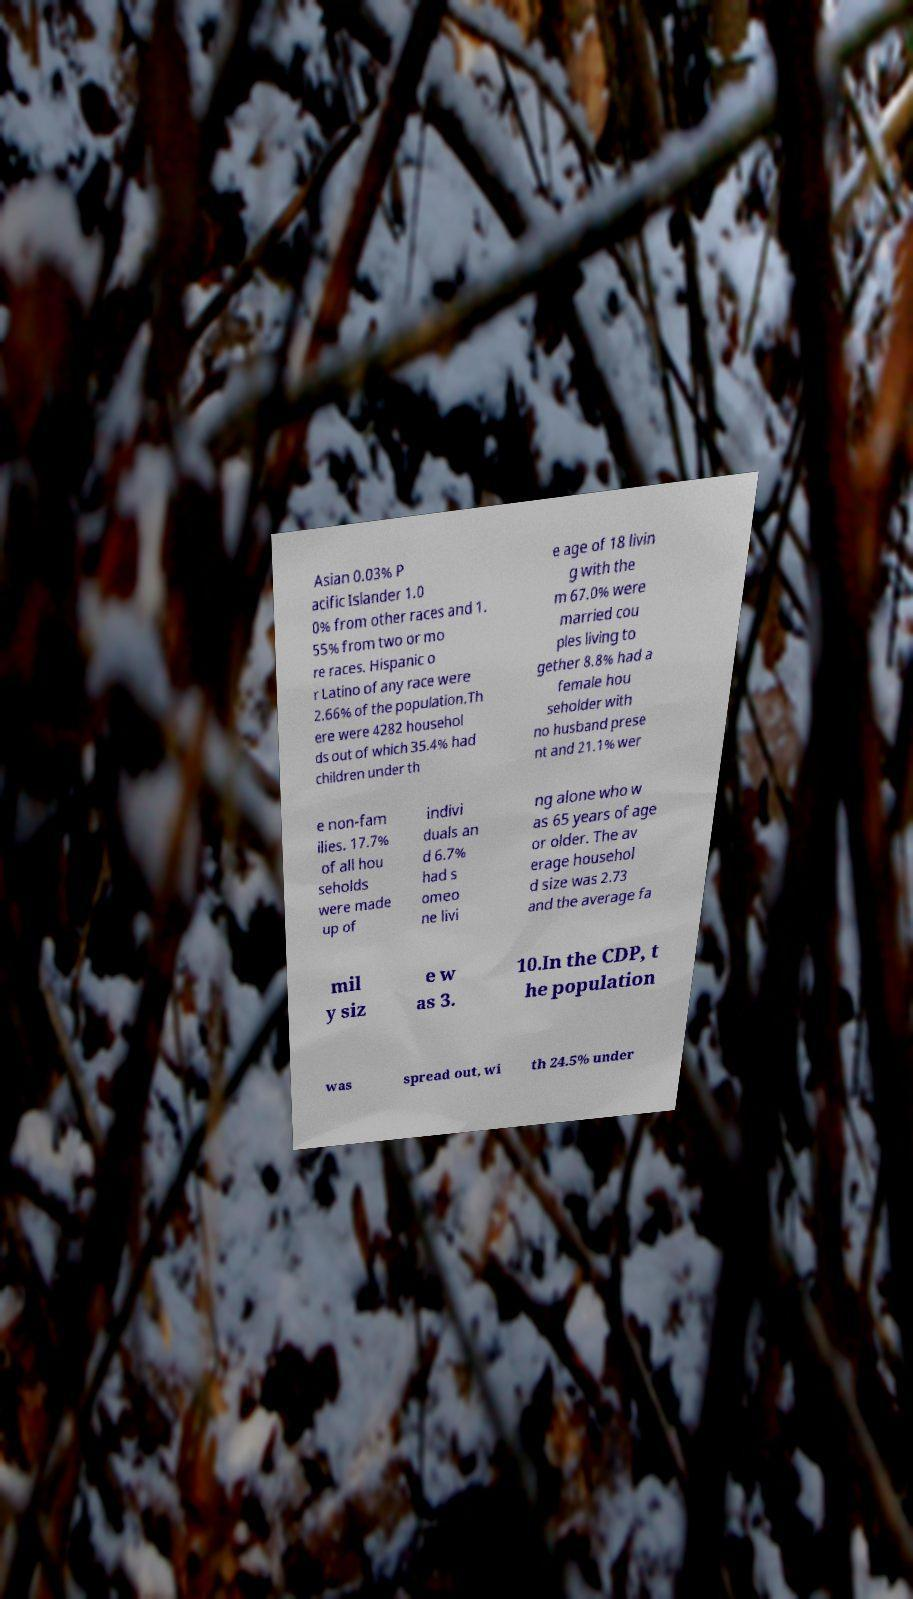I need the written content from this picture converted into text. Can you do that? Asian 0.03% P acific Islander 1.0 0% from other races and 1. 55% from two or mo re races. Hispanic o r Latino of any race were 2.66% of the population.Th ere were 4282 househol ds out of which 35.4% had children under th e age of 18 livin g with the m 67.0% were married cou ples living to gether 8.8% had a female hou seholder with no husband prese nt and 21.1% wer e non-fam ilies. 17.7% of all hou seholds were made up of indivi duals an d 6.7% had s omeo ne livi ng alone who w as 65 years of age or older. The av erage househol d size was 2.73 and the average fa mil y siz e w as 3. 10.In the CDP, t he population was spread out, wi th 24.5% under 